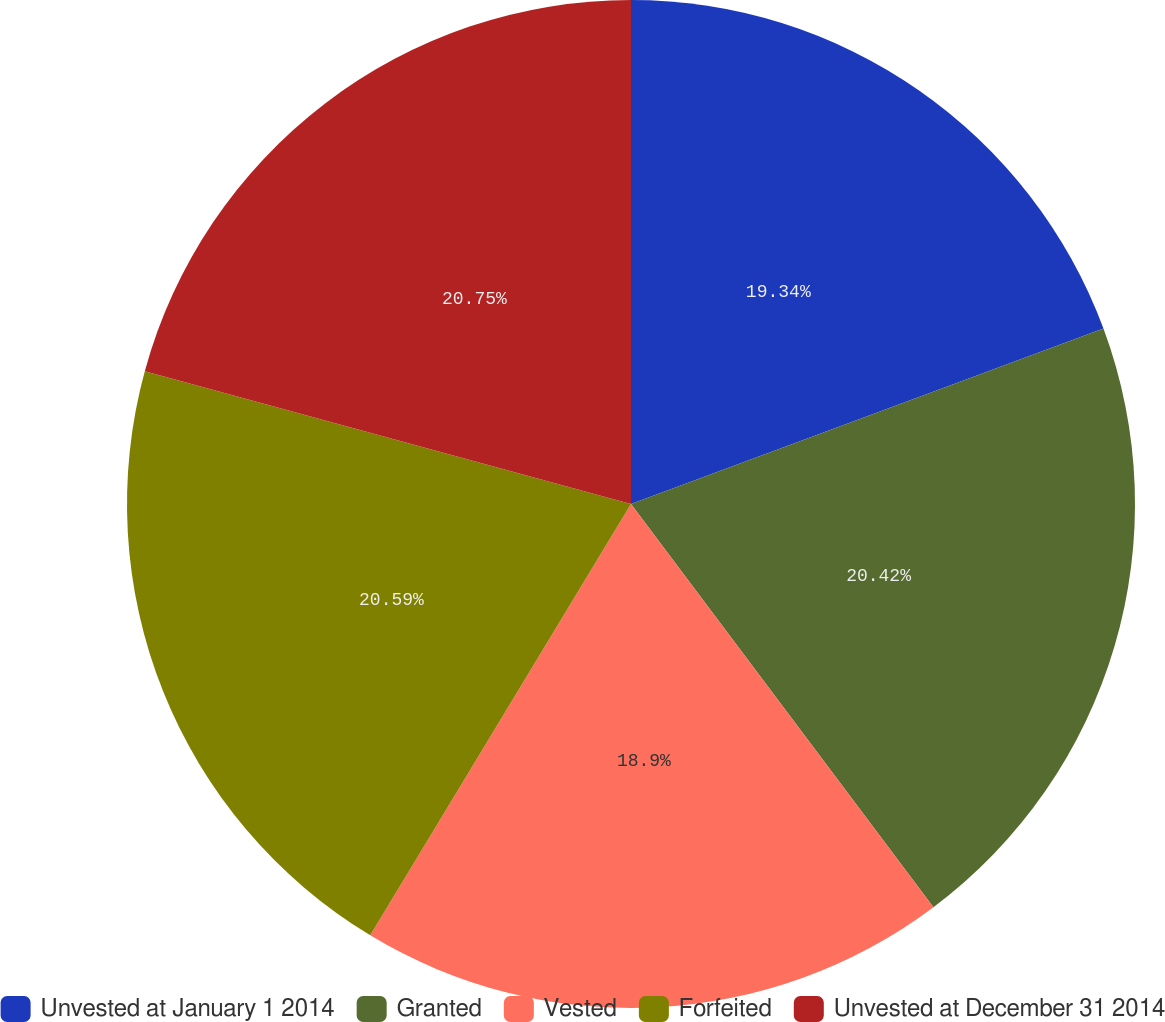Convert chart to OTSL. <chart><loc_0><loc_0><loc_500><loc_500><pie_chart><fcel>Unvested at January 1 2014<fcel>Granted<fcel>Vested<fcel>Forfeited<fcel>Unvested at December 31 2014<nl><fcel>19.34%<fcel>20.42%<fcel>18.9%<fcel>20.59%<fcel>20.76%<nl></chart> 